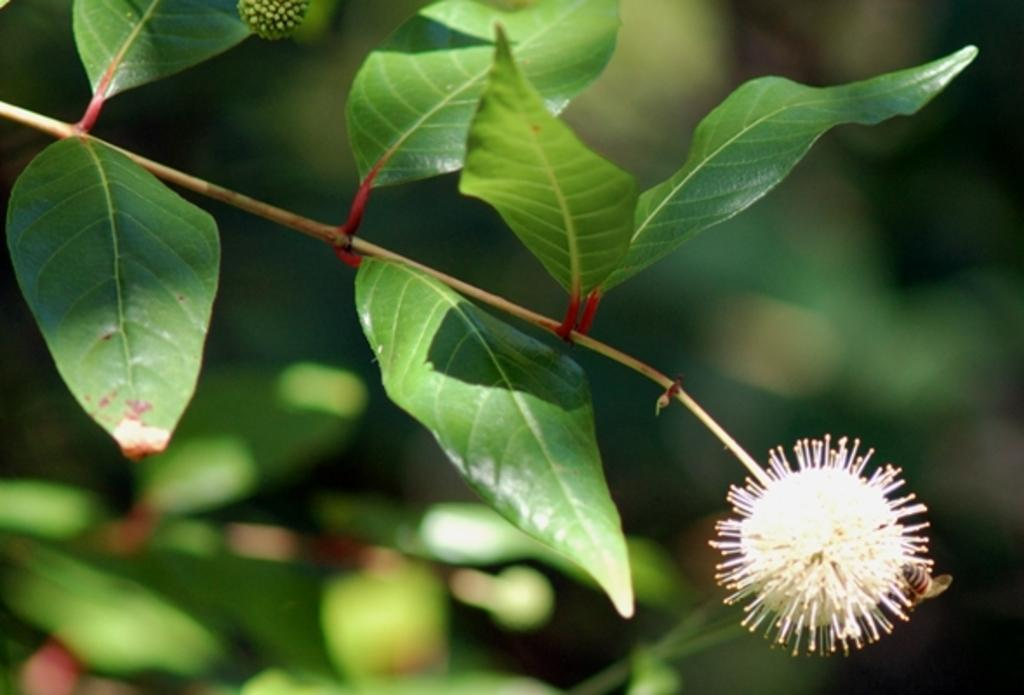What type of plant is in the image? There is a Buttonbush plant in the image. What can be observed about the background of the image? The background of the image is blurred. What other living organism can be seen in the image? There is an insect visible in the image. What type of bucket can be seen holding the plant in the image? There is no bucket present in the image; the plant is not being held by any container. What thrilling activity is taking place in the image? There is no thrilling activity depicted in the image; it features a Buttonbush plant and an insect. 